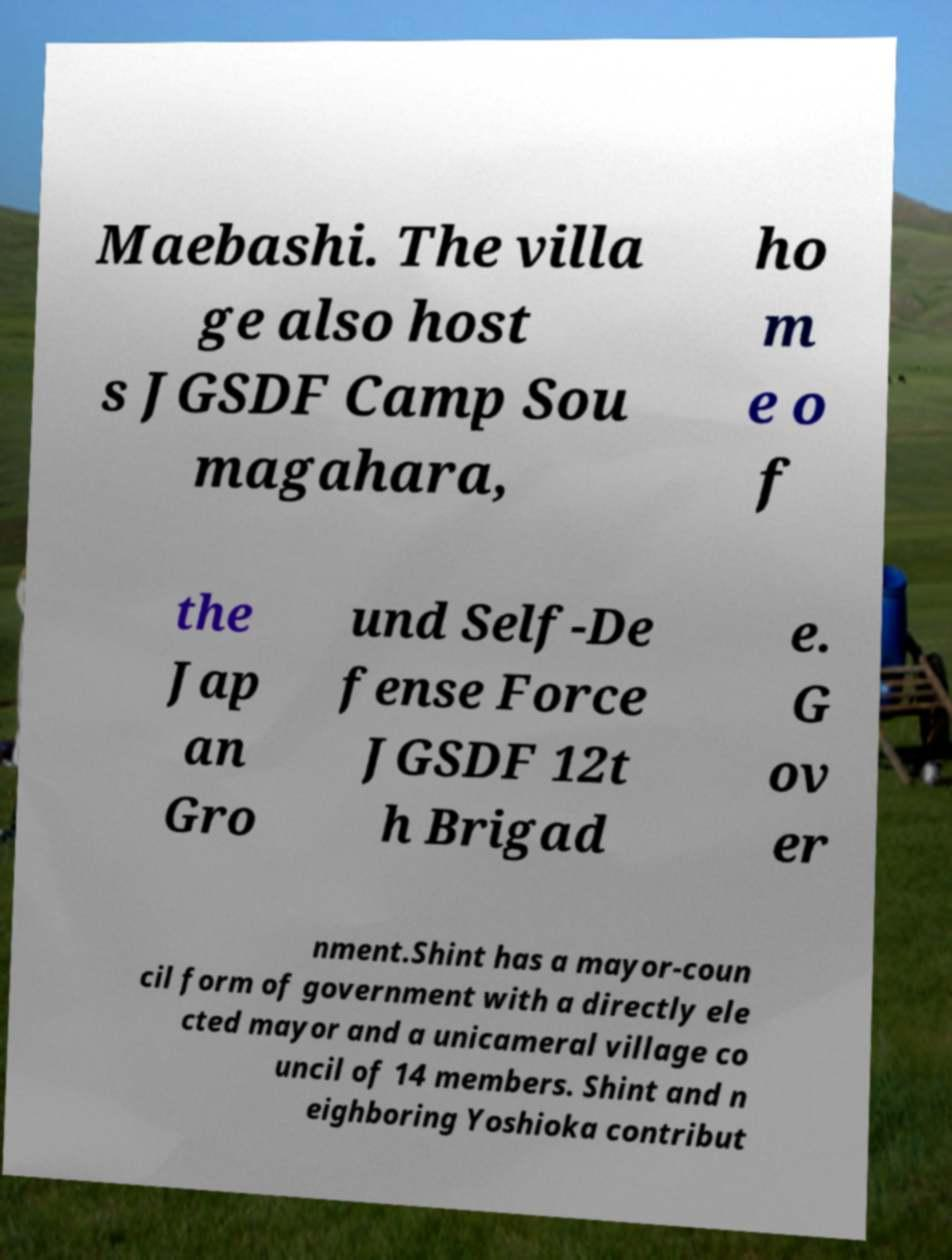Can you read and provide the text displayed in the image?This photo seems to have some interesting text. Can you extract and type it out for me? Maebashi. The villa ge also host s JGSDF Camp Sou magahara, ho m e o f the Jap an Gro und Self-De fense Force JGSDF 12t h Brigad e. G ov er nment.Shint has a mayor-coun cil form of government with a directly ele cted mayor and a unicameral village co uncil of 14 members. Shint and n eighboring Yoshioka contribut 